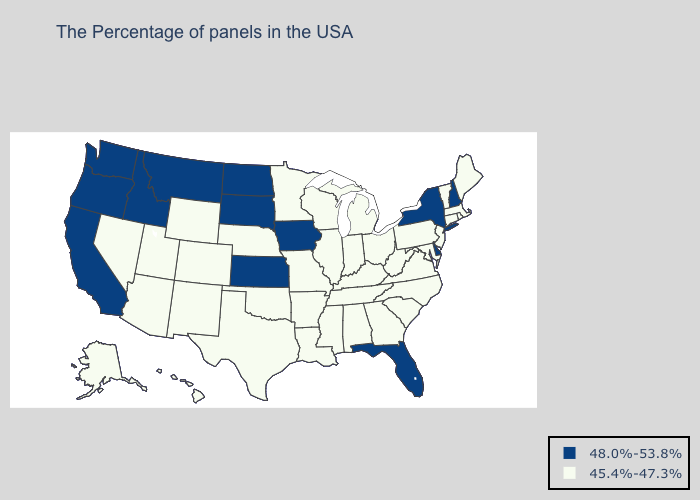Does New York have the lowest value in the Northeast?
Give a very brief answer. No. How many symbols are there in the legend?
Give a very brief answer. 2. Does Delaware have the lowest value in the South?
Keep it brief. No. What is the value of Rhode Island?
Concise answer only. 45.4%-47.3%. Does Hawaii have the same value as Florida?
Short answer required. No. Name the states that have a value in the range 45.4%-47.3%?
Answer briefly. Maine, Massachusetts, Rhode Island, Vermont, Connecticut, New Jersey, Maryland, Pennsylvania, Virginia, North Carolina, South Carolina, West Virginia, Ohio, Georgia, Michigan, Kentucky, Indiana, Alabama, Tennessee, Wisconsin, Illinois, Mississippi, Louisiana, Missouri, Arkansas, Minnesota, Nebraska, Oklahoma, Texas, Wyoming, Colorado, New Mexico, Utah, Arizona, Nevada, Alaska, Hawaii. What is the value of Alaska?
Answer briefly. 45.4%-47.3%. What is the value of Connecticut?
Write a very short answer. 45.4%-47.3%. Which states have the lowest value in the West?
Quick response, please. Wyoming, Colorado, New Mexico, Utah, Arizona, Nevada, Alaska, Hawaii. What is the value of Texas?
Answer briefly. 45.4%-47.3%. Does Florida have the highest value in the South?
Keep it brief. Yes. Does Montana have the lowest value in the West?
Answer briefly. No. Is the legend a continuous bar?
Write a very short answer. No. What is the value of Mississippi?
Answer briefly. 45.4%-47.3%. Name the states that have a value in the range 45.4%-47.3%?
Concise answer only. Maine, Massachusetts, Rhode Island, Vermont, Connecticut, New Jersey, Maryland, Pennsylvania, Virginia, North Carolina, South Carolina, West Virginia, Ohio, Georgia, Michigan, Kentucky, Indiana, Alabama, Tennessee, Wisconsin, Illinois, Mississippi, Louisiana, Missouri, Arkansas, Minnesota, Nebraska, Oklahoma, Texas, Wyoming, Colorado, New Mexico, Utah, Arizona, Nevada, Alaska, Hawaii. 